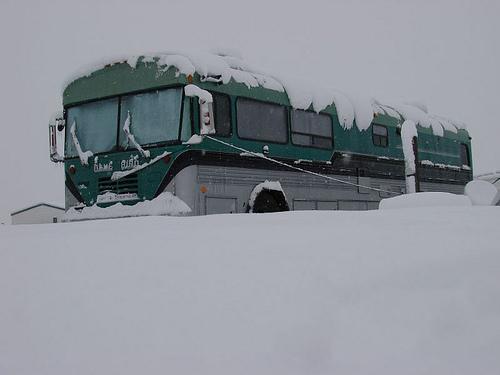How many train cars are there?
Give a very brief answer. 0. 